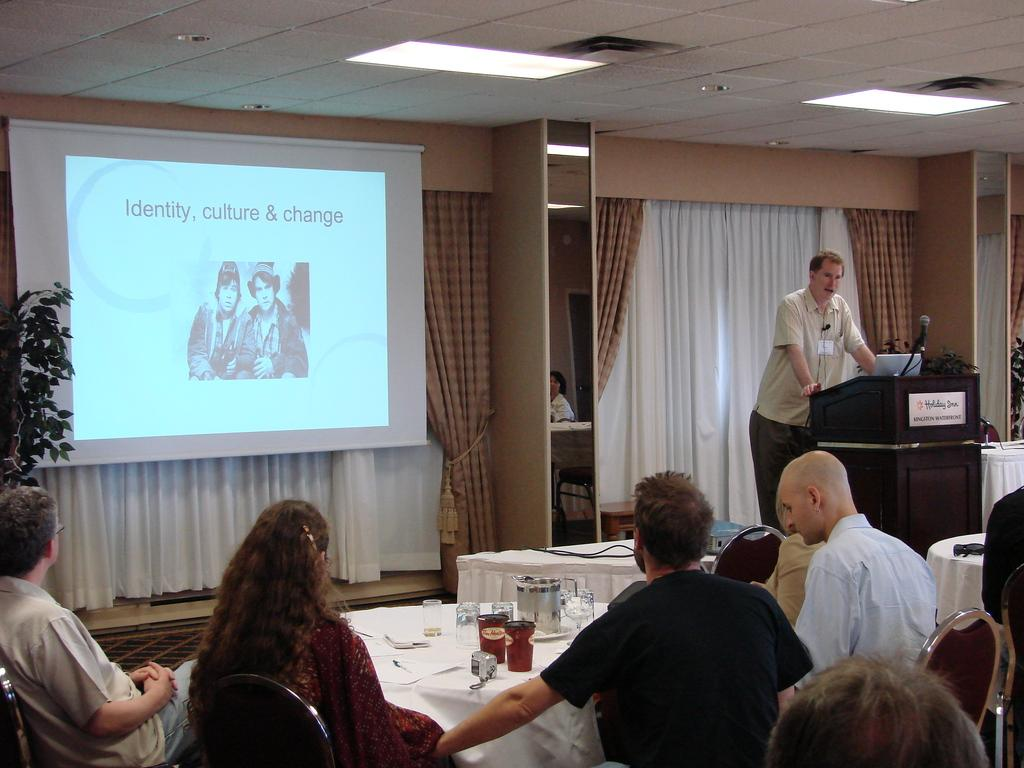<image>
Share a concise interpretation of the image provided. a manspeaks to attendees of a seminar on Culture, Change and Identity 